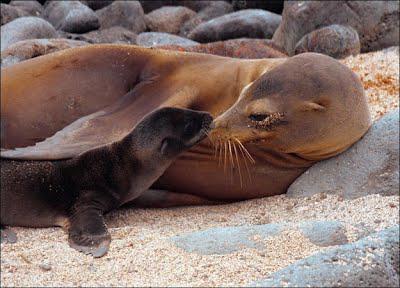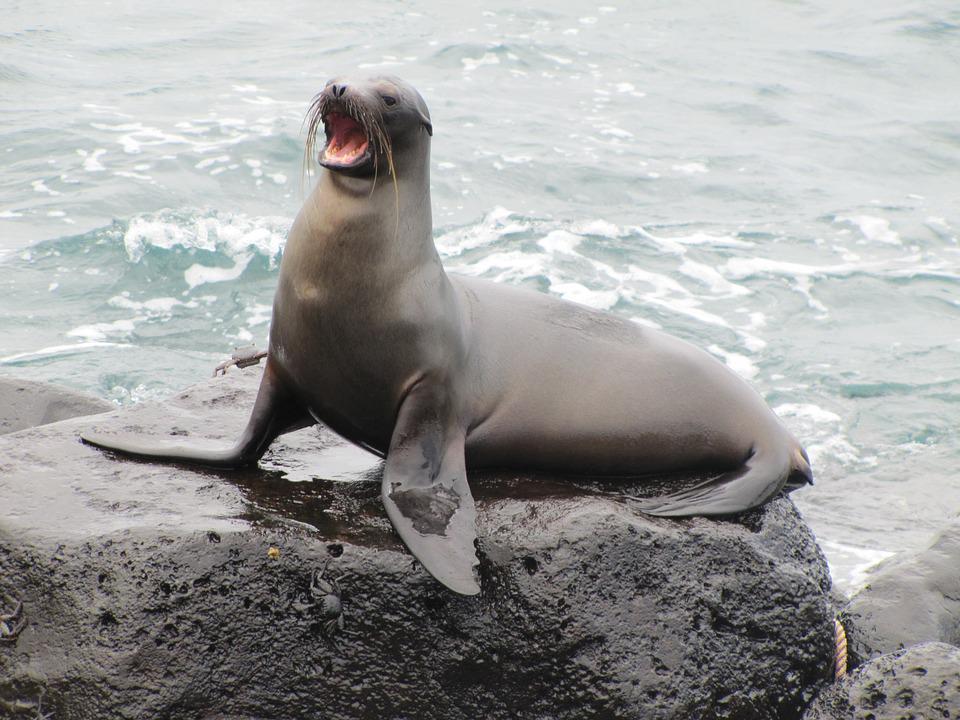The first image is the image on the left, the second image is the image on the right. Assess this claim about the two images: "At least one of the images shows only one sea lion.". Correct or not? Answer yes or no. Yes. The first image is the image on the left, the second image is the image on the right. Considering the images on both sides, is "An image shows exactly one seal, with flippers on a surface in front of its body." valid? Answer yes or no. Yes. 